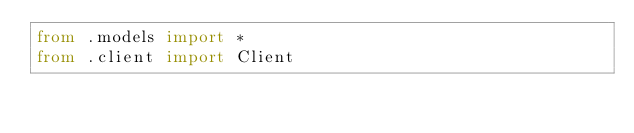<code> <loc_0><loc_0><loc_500><loc_500><_Python_>from .models import *
from .client import Client
</code> 